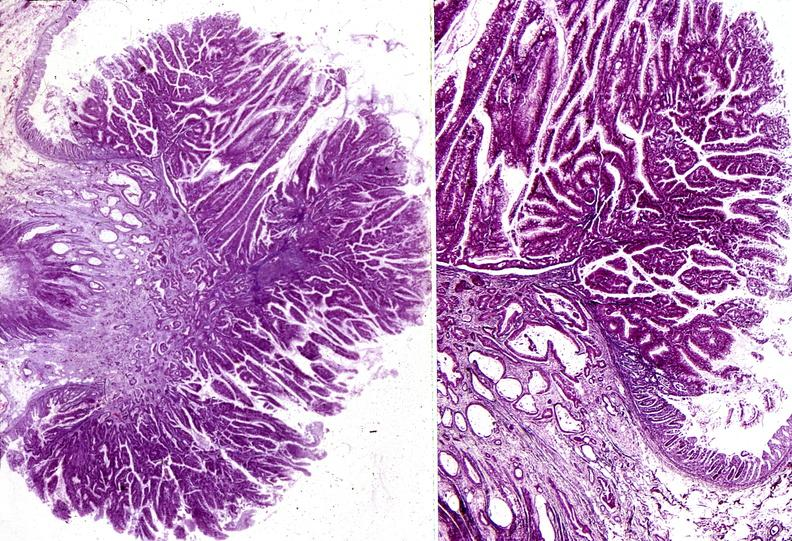where is this from?
Answer the question using a single word or phrase. Gastrointestinal system 